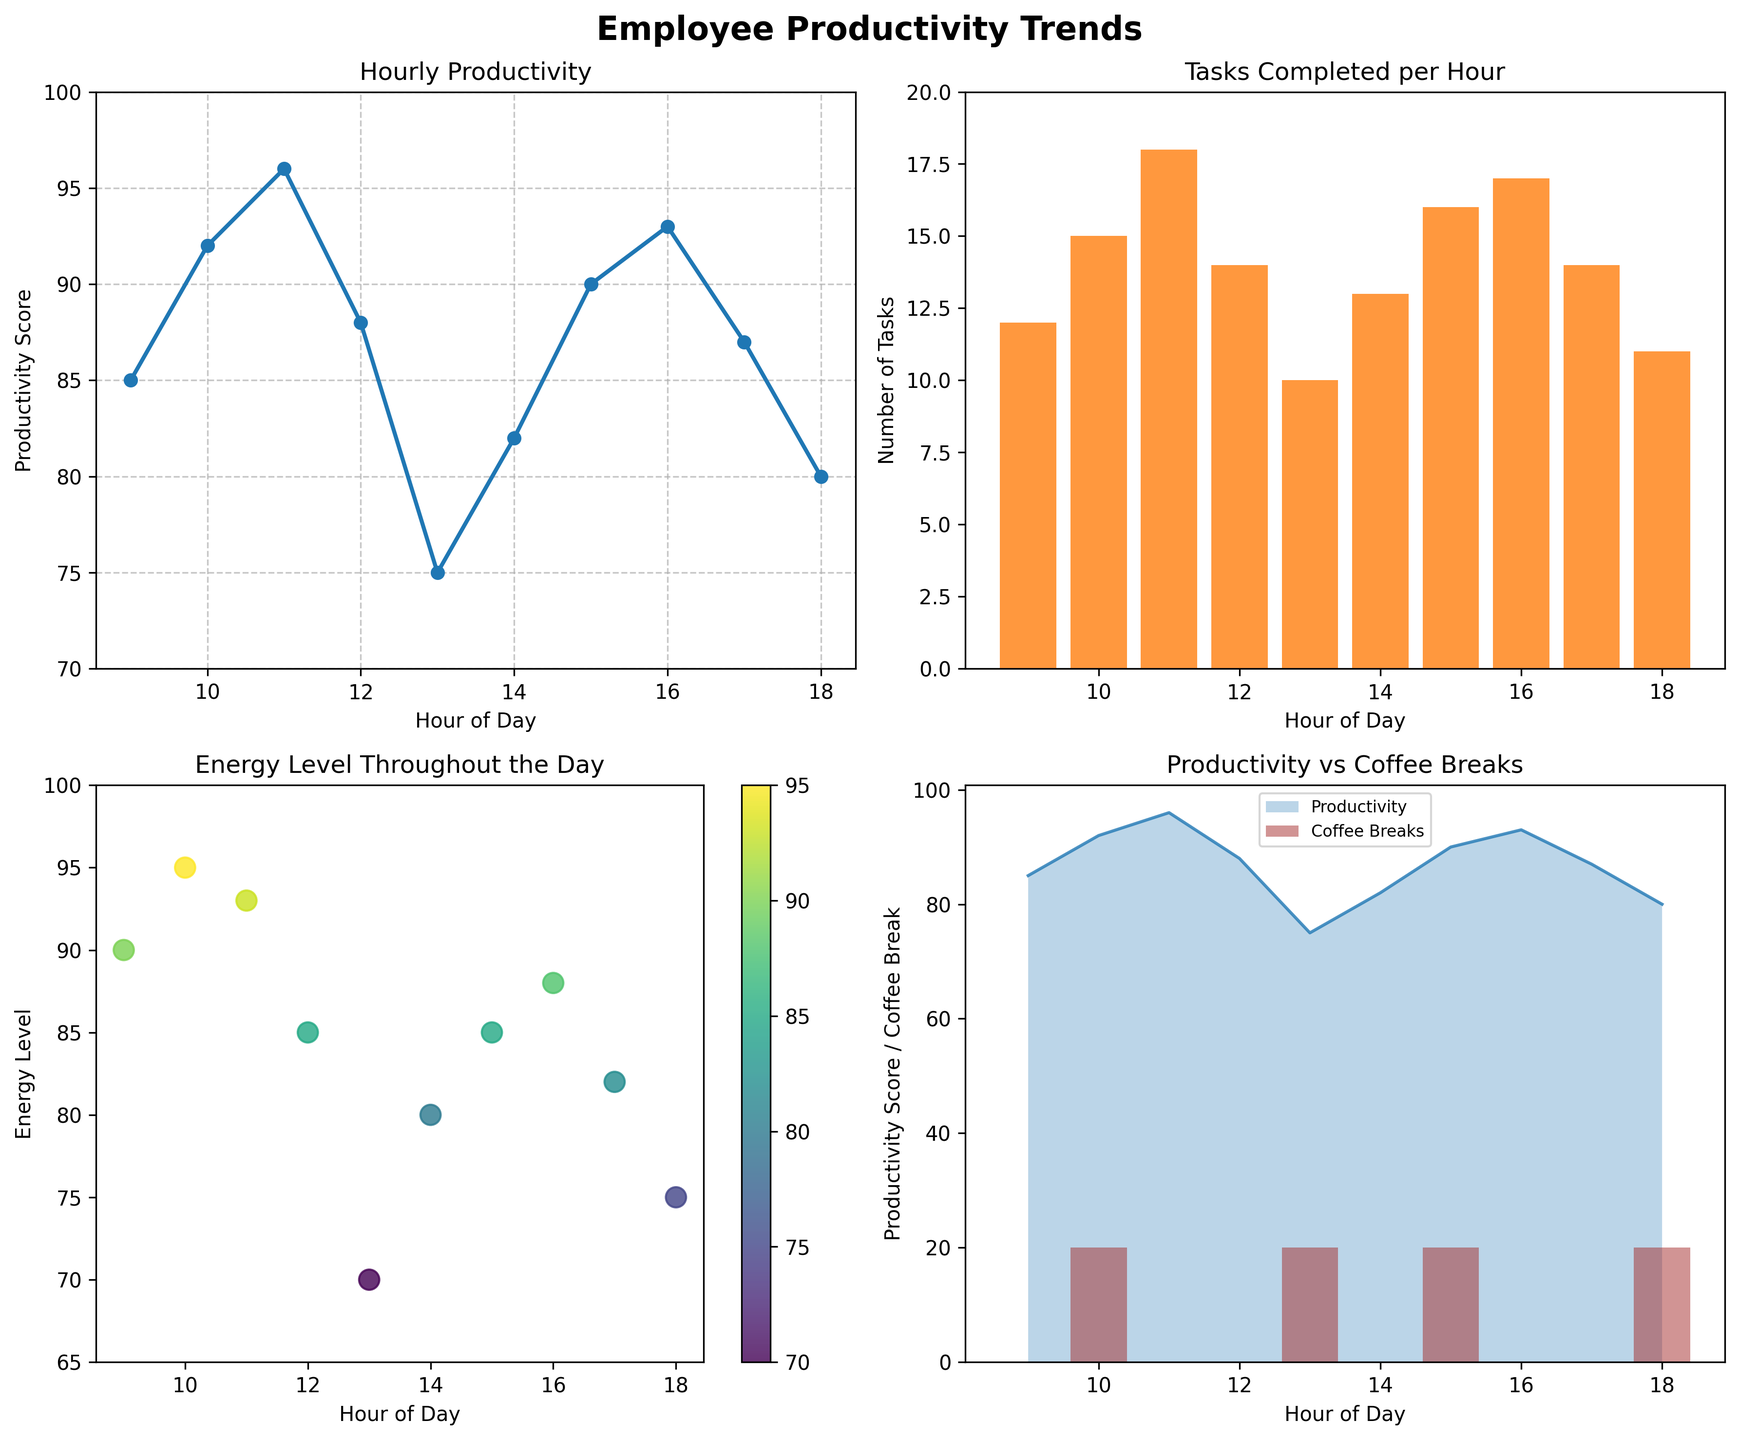What is the trend in productivity throughout the day? The line plot titled "Hourly Productivity" shows a general trend of productivity increasing slightly during the morning hours, peaking at 96 at 11 AM. It then declines to its lowest point at 1 PM with a productivity score of 75, followed by a slight recovery in the afternoon.
Answer: Productivity peaks at 11 AM, dips at 1 PM, and slightly recovers in the afternoon How many tasks were completed at 10 AM and what were the corresponding productivity and energy levels? The bar plot 'Tasks Completed per Hour' shows 15 tasks completed at 10 AM. From the line plot for 'Hourly Productivity,' the score is 92, and from the scatter plot 'Energy Level Throughout the Day,' the energy level is at 95.
Answer: 15 tasks, Productivity: 92, Energy Level: 95 Which hour had the highest energy level? The scatter plot 'Energy Level Throughout the Day' indicates that the highest energy level was 95 at 10 AM.
Answer: 10 AM How does the number of coffee breaks correlate with productivity scores at 1 PM and 3 PM? At 1 PM, the bar for 'Coffee Breaks' indicates 1 break, and the line plot shows a productivity score of 75. At 3 PM, the bar indicates 1 break, and the productivity score is 90. Increasing breaks from 0 to 1 at midday shows an initial decline in productivity, but it recovers later.
Answer: At 1 PM: Coffee Breaks: 1, Productivity: 75; At 3 PM: Coffee Breaks: 1, Productivity: 90 What’s the average productivity score from 9 AM to 6 PM? The productivity scores at each hour are: 85, 92, 96, 88, 75, 82, 90, 93, 87, 80. Summing these values gives a total of 868. The number of hours is 10. So, the average productivity score is 868/10 = 86.8.
Answer: 86.8 Is there a significant drop in productivity after lunch? The bar plot shows a drop in productivity from a peak of 96 at 11 AM to 88 at 12 PM and then it drops further to 75 at 1 PM right after lunch. This indicates a significant decline post-lunch but a slight recovery later.
Answer: Yes, from 96 at 11 AM to 75 at 1 PM How does task completion at 2 PM compare to earlier and later hours? At 2 PM, the bar plot shows 13 tasks completed. Comparing this with 12 PM's 14 tasks and 4 PM's 17 tasks, 2 PM has a lower task completion rate than 4 PM but higher than 12 PM.
Answer: Lower than 4 PM, higher than 12 PM Based on the figure, at what hour could an additional coffee break potentially boost productivity the most? At 2 PM, productivity starts to recover without any coffee break. Introducing a break here might boost the already recovering productivity further, as indicated by a potential increase from the dip earlier in the afternoon.
Answer: 2 PM 